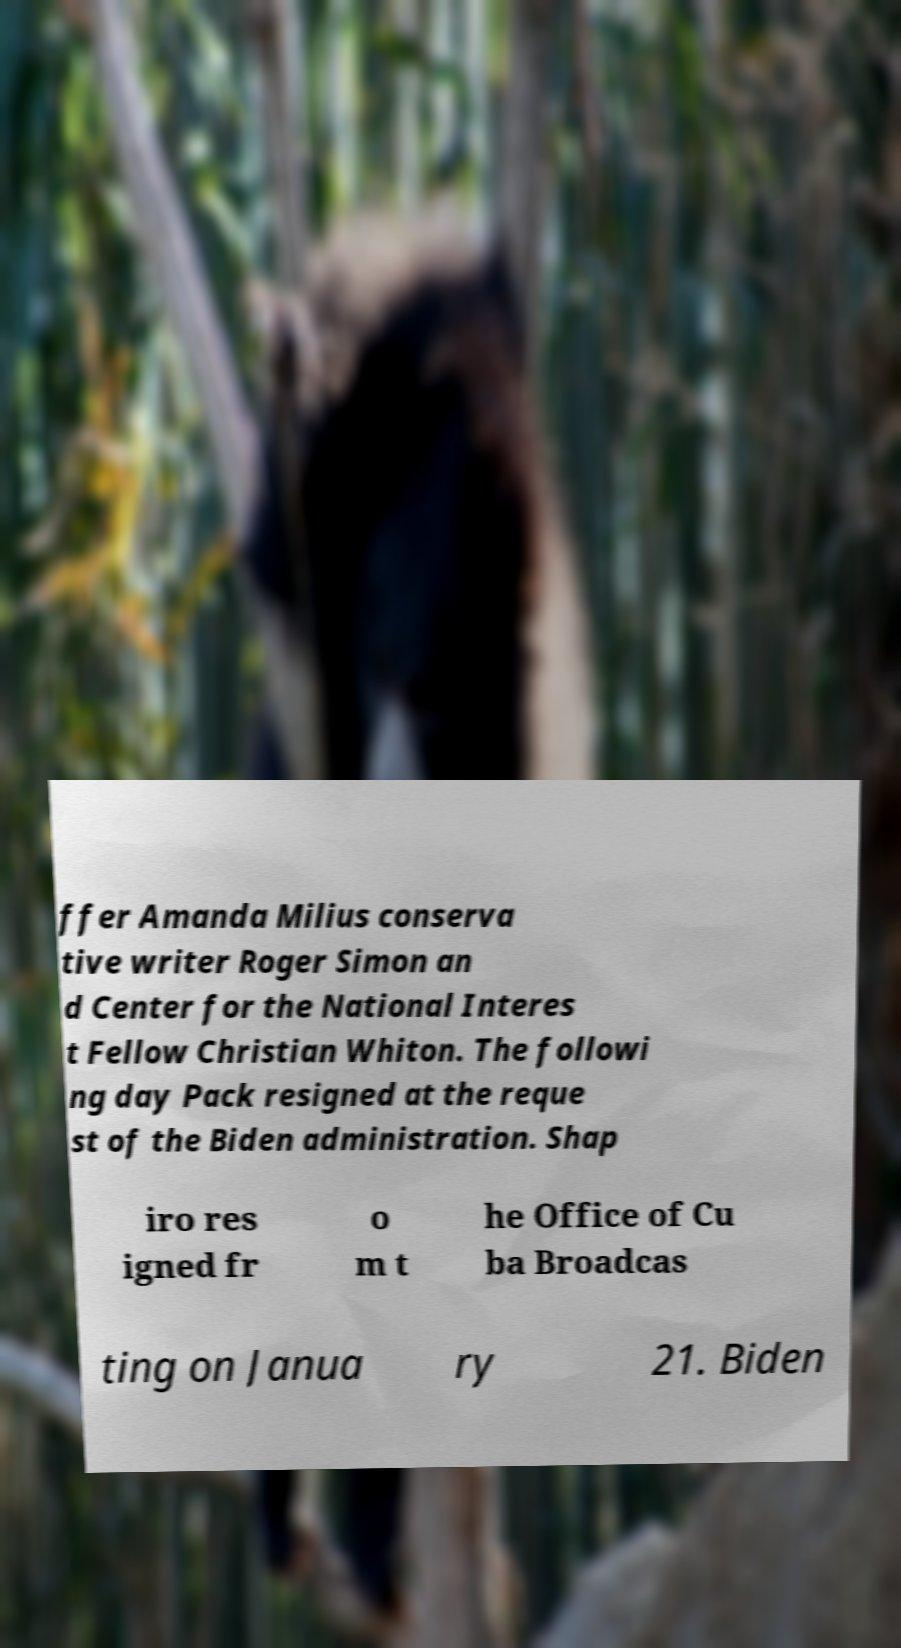Can you accurately transcribe the text from the provided image for me? ffer Amanda Milius conserva tive writer Roger Simon an d Center for the National Interes t Fellow Christian Whiton. The followi ng day Pack resigned at the reque st of the Biden administration. Shap iro res igned fr o m t he Office of Cu ba Broadcas ting on Janua ry 21. Biden 